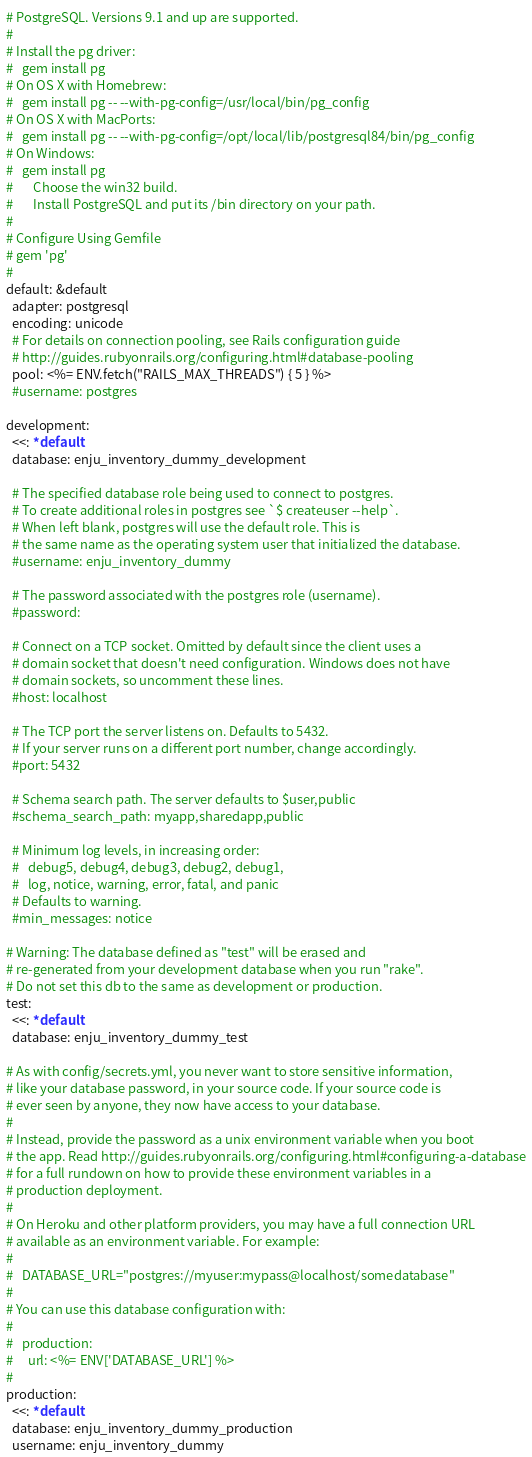<code> <loc_0><loc_0><loc_500><loc_500><_YAML_># PostgreSQL. Versions 9.1 and up are supported.
#
# Install the pg driver:
#   gem install pg
# On OS X with Homebrew:
#   gem install pg -- --with-pg-config=/usr/local/bin/pg_config
# On OS X with MacPorts:
#   gem install pg -- --with-pg-config=/opt/local/lib/postgresql84/bin/pg_config
# On Windows:
#   gem install pg
#       Choose the win32 build.
#       Install PostgreSQL and put its /bin directory on your path.
#
# Configure Using Gemfile
# gem 'pg'
#
default: &default
  adapter: postgresql
  encoding: unicode
  # For details on connection pooling, see Rails configuration guide
  # http://guides.rubyonrails.org/configuring.html#database-pooling
  pool: <%= ENV.fetch("RAILS_MAX_THREADS") { 5 } %>
  #username: postgres

development:
  <<: *default
  database: enju_inventory_dummy_development

  # The specified database role being used to connect to postgres.
  # To create additional roles in postgres see `$ createuser --help`.
  # When left blank, postgres will use the default role. This is
  # the same name as the operating system user that initialized the database.
  #username: enju_inventory_dummy

  # The password associated with the postgres role (username).
  #password:

  # Connect on a TCP socket. Omitted by default since the client uses a
  # domain socket that doesn't need configuration. Windows does not have
  # domain sockets, so uncomment these lines.
  #host: localhost

  # The TCP port the server listens on. Defaults to 5432.
  # If your server runs on a different port number, change accordingly.
  #port: 5432

  # Schema search path. The server defaults to $user,public
  #schema_search_path: myapp,sharedapp,public

  # Minimum log levels, in increasing order:
  #   debug5, debug4, debug3, debug2, debug1,
  #   log, notice, warning, error, fatal, and panic
  # Defaults to warning.
  #min_messages: notice

# Warning: The database defined as "test" will be erased and
# re-generated from your development database when you run "rake".
# Do not set this db to the same as development or production.
test:
  <<: *default
  database: enju_inventory_dummy_test

# As with config/secrets.yml, you never want to store sensitive information,
# like your database password, in your source code. If your source code is
# ever seen by anyone, they now have access to your database.
#
# Instead, provide the password as a unix environment variable when you boot
# the app. Read http://guides.rubyonrails.org/configuring.html#configuring-a-database
# for a full rundown on how to provide these environment variables in a
# production deployment.
#
# On Heroku and other platform providers, you may have a full connection URL
# available as an environment variable. For example:
#
#   DATABASE_URL="postgres://myuser:mypass@localhost/somedatabase"
#
# You can use this database configuration with:
#
#   production:
#     url: <%= ENV['DATABASE_URL'] %>
#
production:
  <<: *default
  database: enju_inventory_dummy_production
  username: enju_inventory_dummy</code> 